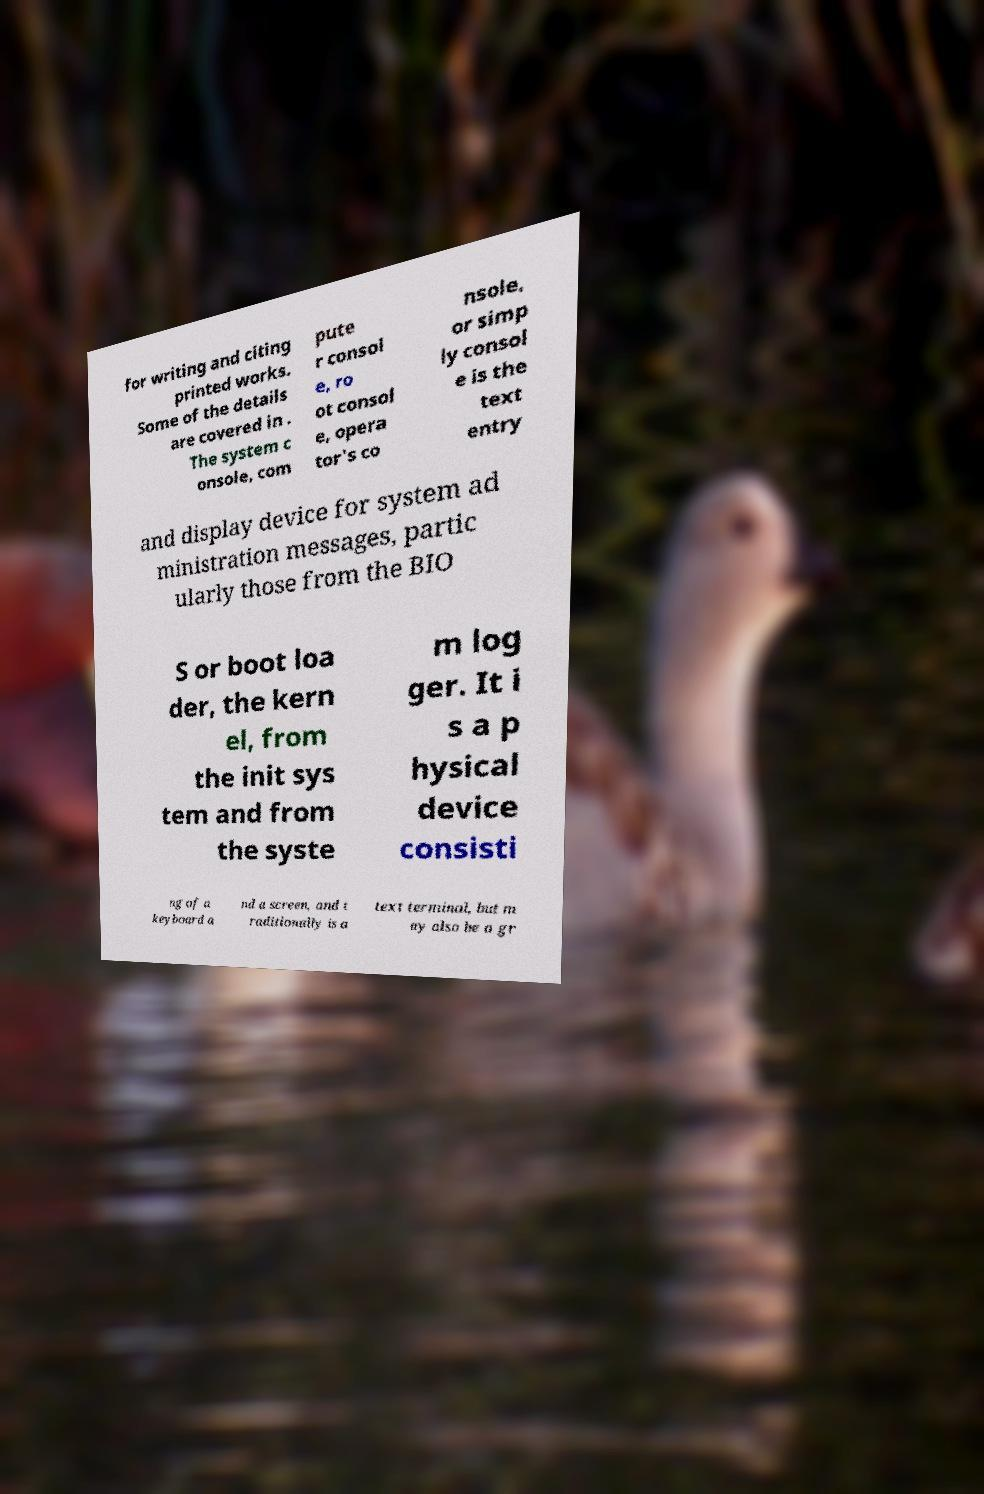I need the written content from this picture converted into text. Can you do that? for writing and citing printed works. Some of the details are covered in . The system c onsole, com pute r consol e, ro ot consol e, opera tor's co nsole, or simp ly consol e is the text entry and display device for system ad ministration messages, partic ularly those from the BIO S or boot loa der, the kern el, from the init sys tem and from the syste m log ger. It i s a p hysical device consisti ng of a keyboard a nd a screen, and t raditionally is a text terminal, but m ay also be a gr 